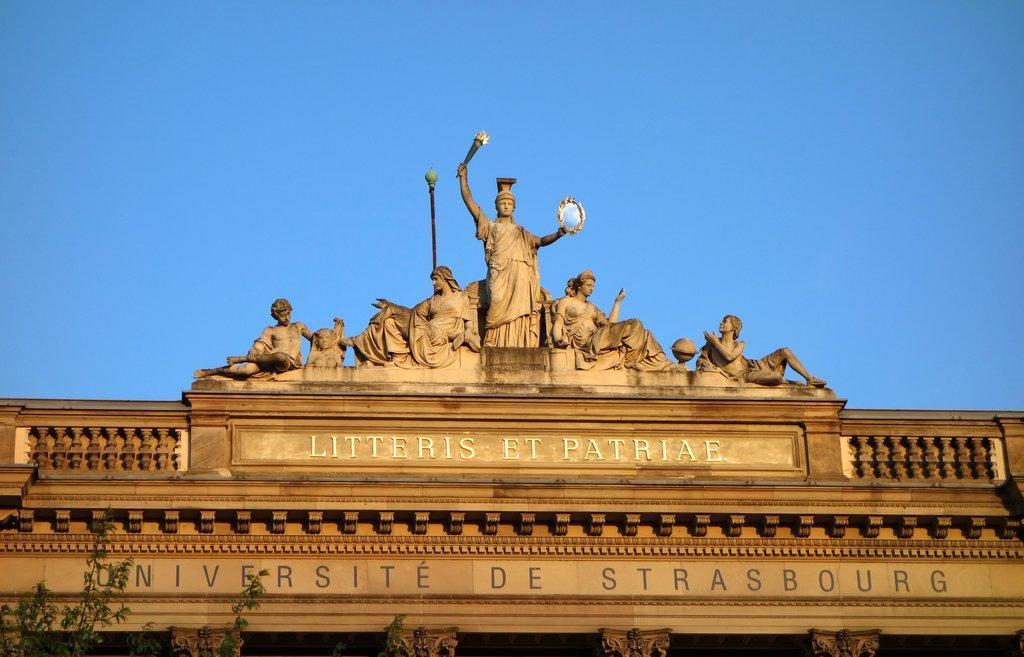Please provide a concise description of this image. In this picture I can see sculptures and text and I can see trees and a blue sky 